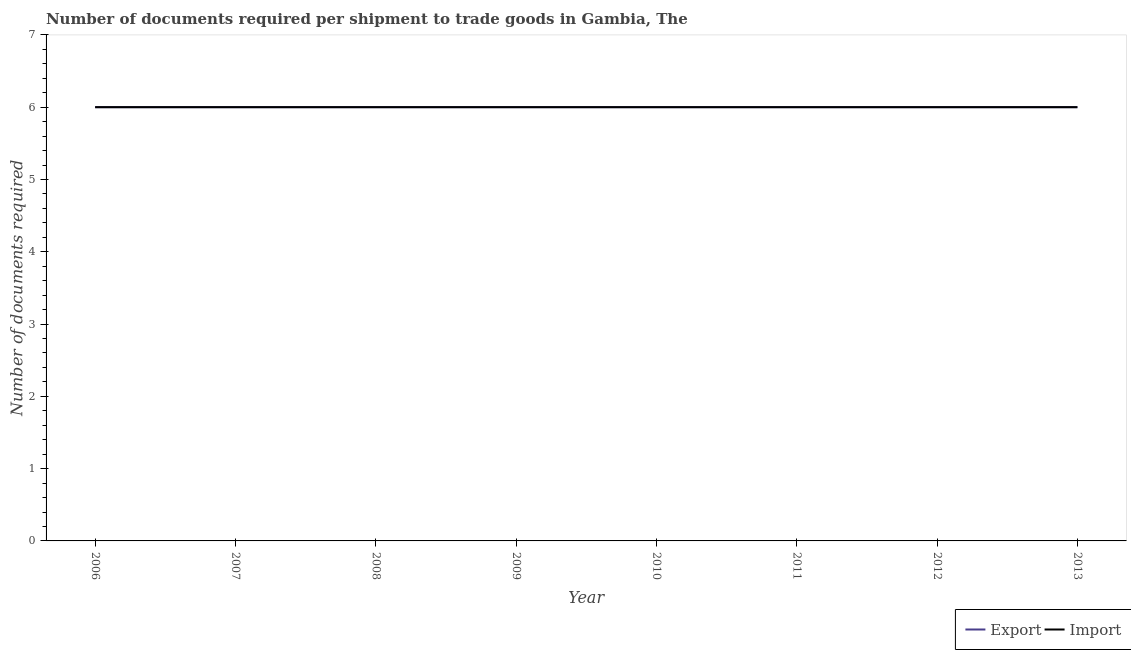How many different coloured lines are there?
Give a very brief answer. 2. Is the number of lines equal to the number of legend labels?
Your response must be concise. Yes. Across all years, what is the minimum number of documents required to import goods?
Provide a succinct answer. 6. In which year was the number of documents required to export goods maximum?
Your answer should be very brief. 2006. In which year was the number of documents required to import goods minimum?
Give a very brief answer. 2006. What is the total number of documents required to import goods in the graph?
Ensure brevity in your answer.  48. What is the difference between the number of documents required to export goods in 2006 and that in 2013?
Your response must be concise. 0. What is the average number of documents required to import goods per year?
Provide a short and direct response. 6. In the year 2007, what is the difference between the number of documents required to export goods and number of documents required to import goods?
Provide a succinct answer. 0. In how many years, is the number of documents required to export goods greater than 5.4?
Your response must be concise. 8. What is the ratio of the number of documents required to export goods in 2008 to that in 2010?
Ensure brevity in your answer.  1. What is the difference between the highest and the lowest number of documents required to import goods?
Offer a terse response. 0. In how many years, is the number of documents required to export goods greater than the average number of documents required to export goods taken over all years?
Your answer should be compact. 0. Is the sum of the number of documents required to export goods in 2006 and 2012 greater than the maximum number of documents required to import goods across all years?
Offer a terse response. Yes. Is the number of documents required to export goods strictly greater than the number of documents required to import goods over the years?
Keep it short and to the point. No. How many lines are there?
Provide a succinct answer. 2. How many years are there in the graph?
Your answer should be compact. 8. Does the graph contain any zero values?
Provide a short and direct response. No. Where does the legend appear in the graph?
Make the answer very short. Bottom right. How many legend labels are there?
Ensure brevity in your answer.  2. What is the title of the graph?
Offer a terse response. Number of documents required per shipment to trade goods in Gambia, The. Does "Secondary education" appear as one of the legend labels in the graph?
Ensure brevity in your answer.  No. What is the label or title of the Y-axis?
Your response must be concise. Number of documents required. What is the Number of documents required in Export in 2006?
Offer a terse response. 6. What is the Number of documents required in Import in 2006?
Your answer should be very brief. 6. What is the Number of documents required of Export in 2007?
Give a very brief answer. 6. What is the Number of documents required of Export in 2010?
Provide a short and direct response. 6. What is the Number of documents required in Import in 2011?
Offer a very short reply. 6. What is the Number of documents required in Export in 2012?
Your answer should be very brief. 6. Across all years, what is the minimum Number of documents required in Export?
Offer a very short reply. 6. Across all years, what is the minimum Number of documents required of Import?
Make the answer very short. 6. What is the total Number of documents required of Export in the graph?
Keep it short and to the point. 48. What is the difference between the Number of documents required of Export in 2006 and that in 2008?
Your answer should be compact. 0. What is the difference between the Number of documents required of Import in 2006 and that in 2008?
Give a very brief answer. 0. What is the difference between the Number of documents required of Export in 2006 and that in 2009?
Give a very brief answer. 0. What is the difference between the Number of documents required in Import in 2006 and that in 2009?
Your answer should be compact. 0. What is the difference between the Number of documents required in Import in 2006 and that in 2010?
Your answer should be very brief. 0. What is the difference between the Number of documents required in Export in 2006 and that in 2011?
Make the answer very short. 0. What is the difference between the Number of documents required in Import in 2006 and that in 2011?
Your answer should be very brief. 0. What is the difference between the Number of documents required in Export in 2007 and that in 2008?
Ensure brevity in your answer.  0. What is the difference between the Number of documents required in Import in 2007 and that in 2008?
Keep it short and to the point. 0. What is the difference between the Number of documents required of Import in 2007 and that in 2009?
Make the answer very short. 0. What is the difference between the Number of documents required in Export in 2007 and that in 2010?
Make the answer very short. 0. What is the difference between the Number of documents required of Import in 2007 and that in 2010?
Your answer should be very brief. 0. What is the difference between the Number of documents required of Export in 2007 and that in 2013?
Offer a very short reply. 0. What is the difference between the Number of documents required in Import in 2007 and that in 2013?
Provide a short and direct response. 0. What is the difference between the Number of documents required in Export in 2008 and that in 2009?
Your answer should be compact. 0. What is the difference between the Number of documents required in Import in 2008 and that in 2010?
Give a very brief answer. 0. What is the difference between the Number of documents required in Export in 2008 and that in 2012?
Ensure brevity in your answer.  0. What is the difference between the Number of documents required of Import in 2008 and that in 2012?
Offer a very short reply. 0. What is the difference between the Number of documents required in Import in 2009 and that in 2011?
Give a very brief answer. 0. What is the difference between the Number of documents required in Import in 2009 and that in 2012?
Ensure brevity in your answer.  0. What is the difference between the Number of documents required in Export in 2009 and that in 2013?
Provide a succinct answer. 0. What is the difference between the Number of documents required in Export in 2010 and that in 2011?
Your answer should be compact. 0. What is the difference between the Number of documents required in Import in 2010 and that in 2011?
Your response must be concise. 0. What is the difference between the Number of documents required in Export in 2010 and that in 2012?
Your answer should be very brief. 0. What is the difference between the Number of documents required of Export in 2010 and that in 2013?
Provide a short and direct response. 0. What is the difference between the Number of documents required in Import in 2010 and that in 2013?
Offer a terse response. 0. What is the difference between the Number of documents required in Import in 2011 and that in 2012?
Your answer should be compact. 0. What is the difference between the Number of documents required in Import in 2011 and that in 2013?
Your answer should be compact. 0. What is the difference between the Number of documents required in Export in 2012 and that in 2013?
Keep it short and to the point. 0. What is the difference between the Number of documents required of Export in 2006 and the Number of documents required of Import in 2007?
Provide a succinct answer. 0. What is the difference between the Number of documents required of Export in 2006 and the Number of documents required of Import in 2008?
Your answer should be very brief. 0. What is the difference between the Number of documents required in Export in 2006 and the Number of documents required in Import in 2009?
Your answer should be compact. 0. What is the difference between the Number of documents required of Export in 2006 and the Number of documents required of Import in 2011?
Provide a short and direct response. 0. What is the difference between the Number of documents required of Export in 2006 and the Number of documents required of Import in 2012?
Offer a terse response. 0. What is the difference between the Number of documents required of Export in 2007 and the Number of documents required of Import in 2010?
Offer a terse response. 0. What is the difference between the Number of documents required in Export in 2007 and the Number of documents required in Import in 2012?
Ensure brevity in your answer.  0. What is the difference between the Number of documents required in Export in 2007 and the Number of documents required in Import in 2013?
Give a very brief answer. 0. What is the difference between the Number of documents required of Export in 2008 and the Number of documents required of Import in 2009?
Give a very brief answer. 0. What is the difference between the Number of documents required of Export in 2008 and the Number of documents required of Import in 2010?
Offer a terse response. 0. What is the difference between the Number of documents required in Export in 2008 and the Number of documents required in Import in 2011?
Keep it short and to the point. 0. What is the difference between the Number of documents required in Export in 2008 and the Number of documents required in Import in 2012?
Your answer should be very brief. 0. What is the difference between the Number of documents required of Export in 2008 and the Number of documents required of Import in 2013?
Provide a short and direct response. 0. What is the difference between the Number of documents required in Export in 2009 and the Number of documents required in Import in 2010?
Your answer should be very brief. 0. What is the difference between the Number of documents required of Export in 2009 and the Number of documents required of Import in 2011?
Provide a succinct answer. 0. What is the difference between the Number of documents required of Export in 2009 and the Number of documents required of Import in 2012?
Give a very brief answer. 0. What is the difference between the Number of documents required in Export in 2009 and the Number of documents required in Import in 2013?
Provide a succinct answer. 0. What is the difference between the Number of documents required of Export in 2011 and the Number of documents required of Import in 2013?
Provide a short and direct response. 0. What is the average Number of documents required of Export per year?
Keep it short and to the point. 6. What is the average Number of documents required of Import per year?
Keep it short and to the point. 6. In the year 2006, what is the difference between the Number of documents required of Export and Number of documents required of Import?
Keep it short and to the point. 0. In the year 2008, what is the difference between the Number of documents required in Export and Number of documents required in Import?
Provide a short and direct response. 0. In the year 2009, what is the difference between the Number of documents required in Export and Number of documents required in Import?
Your response must be concise. 0. In the year 2010, what is the difference between the Number of documents required of Export and Number of documents required of Import?
Give a very brief answer. 0. In the year 2011, what is the difference between the Number of documents required in Export and Number of documents required in Import?
Your answer should be very brief. 0. In the year 2012, what is the difference between the Number of documents required of Export and Number of documents required of Import?
Make the answer very short. 0. What is the ratio of the Number of documents required of Export in 2006 to that in 2007?
Ensure brevity in your answer.  1. What is the ratio of the Number of documents required of Import in 2006 to that in 2008?
Offer a terse response. 1. What is the ratio of the Number of documents required in Export in 2006 to that in 2009?
Keep it short and to the point. 1. What is the ratio of the Number of documents required of Import in 2006 to that in 2009?
Keep it short and to the point. 1. What is the ratio of the Number of documents required of Export in 2006 to that in 2010?
Make the answer very short. 1. What is the ratio of the Number of documents required in Import in 2006 to that in 2010?
Make the answer very short. 1. What is the ratio of the Number of documents required of Export in 2006 to that in 2011?
Your answer should be very brief. 1. What is the ratio of the Number of documents required of Import in 2006 to that in 2012?
Offer a terse response. 1. What is the ratio of the Number of documents required of Export in 2006 to that in 2013?
Offer a very short reply. 1. What is the ratio of the Number of documents required in Import in 2006 to that in 2013?
Provide a short and direct response. 1. What is the ratio of the Number of documents required in Export in 2007 to that in 2008?
Offer a very short reply. 1. What is the ratio of the Number of documents required of Import in 2007 to that in 2008?
Make the answer very short. 1. What is the ratio of the Number of documents required of Export in 2007 to that in 2009?
Offer a very short reply. 1. What is the ratio of the Number of documents required of Import in 2007 to that in 2010?
Your answer should be compact. 1. What is the ratio of the Number of documents required of Export in 2007 to that in 2011?
Your answer should be compact. 1. What is the ratio of the Number of documents required of Import in 2007 to that in 2011?
Make the answer very short. 1. What is the ratio of the Number of documents required in Export in 2007 to that in 2012?
Provide a short and direct response. 1. What is the ratio of the Number of documents required of Export in 2008 to that in 2009?
Ensure brevity in your answer.  1. What is the ratio of the Number of documents required in Import in 2008 to that in 2009?
Make the answer very short. 1. What is the ratio of the Number of documents required of Export in 2008 to that in 2010?
Offer a very short reply. 1. What is the ratio of the Number of documents required in Import in 2008 to that in 2012?
Keep it short and to the point. 1. What is the ratio of the Number of documents required of Export in 2008 to that in 2013?
Offer a terse response. 1. What is the ratio of the Number of documents required of Import in 2009 to that in 2010?
Make the answer very short. 1. What is the ratio of the Number of documents required of Export in 2009 to that in 2013?
Provide a succinct answer. 1. What is the ratio of the Number of documents required of Export in 2010 to that in 2011?
Make the answer very short. 1. What is the ratio of the Number of documents required of Import in 2010 to that in 2011?
Provide a succinct answer. 1. What is the ratio of the Number of documents required in Export in 2010 to that in 2012?
Keep it short and to the point. 1. What is the ratio of the Number of documents required of Import in 2010 to that in 2012?
Provide a succinct answer. 1. What is the ratio of the Number of documents required of Export in 2010 to that in 2013?
Make the answer very short. 1. What is the difference between the highest and the lowest Number of documents required in Import?
Provide a succinct answer. 0. 